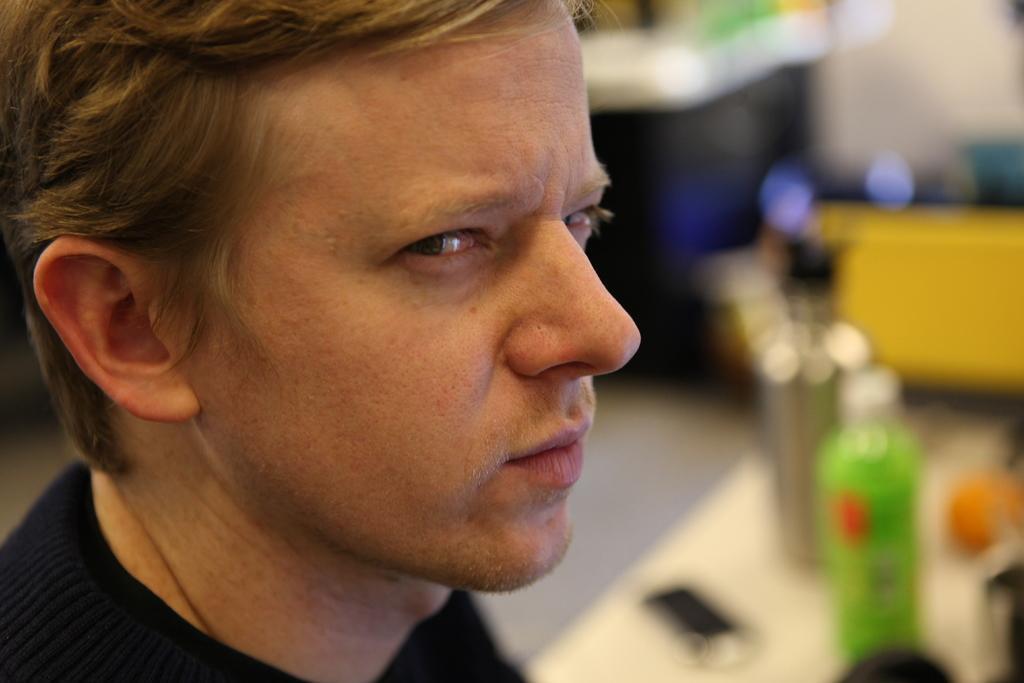Please provide a concise description of this image. In this picture I can see a man and couple of bottles on the table and I can see blurry background. 